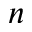<formula> <loc_0><loc_0><loc_500><loc_500>n</formula> 